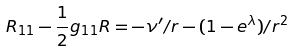<formula> <loc_0><loc_0><loc_500><loc_500>R _ { 1 1 } - \frac { 1 } { 2 } g _ { 1 1 } R = - \nu ^ { \prime } / r - ( 1 - e ^ { \lambda } ) / r ^ { 2 }</formula> 